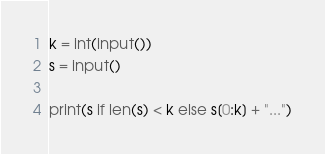<code> <loc_0><loc_0><loc_500><loc_500><_Python_>k = int(input())
s = input()

print(s if len(s) < k else s[0:k] + "...")</code> 